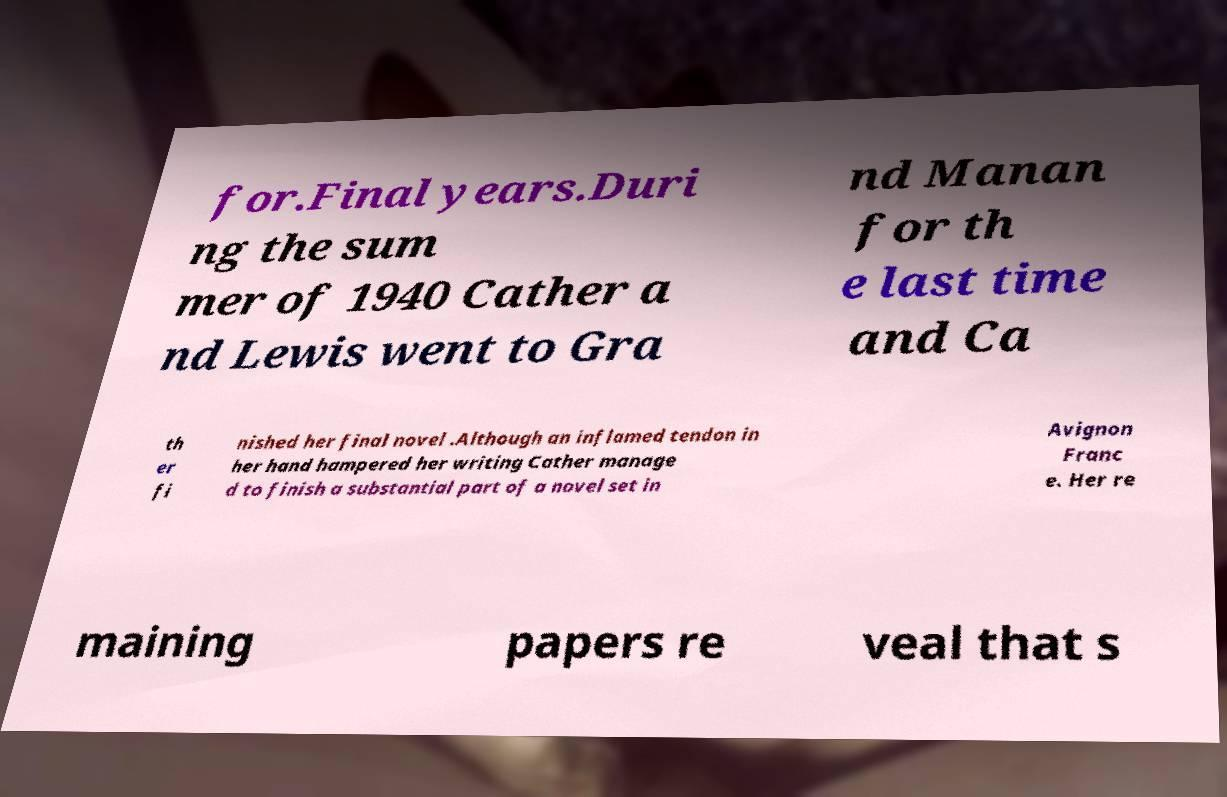Can you accurately transcribe the text from the provided image for me? for.Final years.Duri ng the sum mer of 1940 Cather a nd Lewis went to Gra nd Manan for th e last time and Ca th er fi nished her final novel .Although an inflamed tendon in her hand hampered her writing Cather manage d to finish a substantial part of a novel set in Avignon Franc e. Her re maining papers re veal that s 